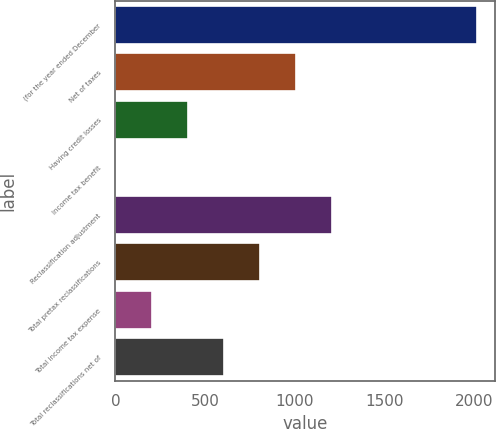Convert chart to OTSL. <chart><loc_0><loc_0><loc_500><loc_500><bar_chart><fcel>(for the year ended December<fcel>Net of taxes<fcel>Having credit losses<fcel>Income tax benefit<fcel>Reclassification adjustment<fcel>Total pretax reclassifications<fcel>Total income tax expense<fcel>Total reclassifications net of<nl><fcel>2012<fcel>1007.5<fcel>404.8<fcel>3<fcel>1208.4<fcel>806.6<fcel>203.9<fcel>605.7<nl></chart> 